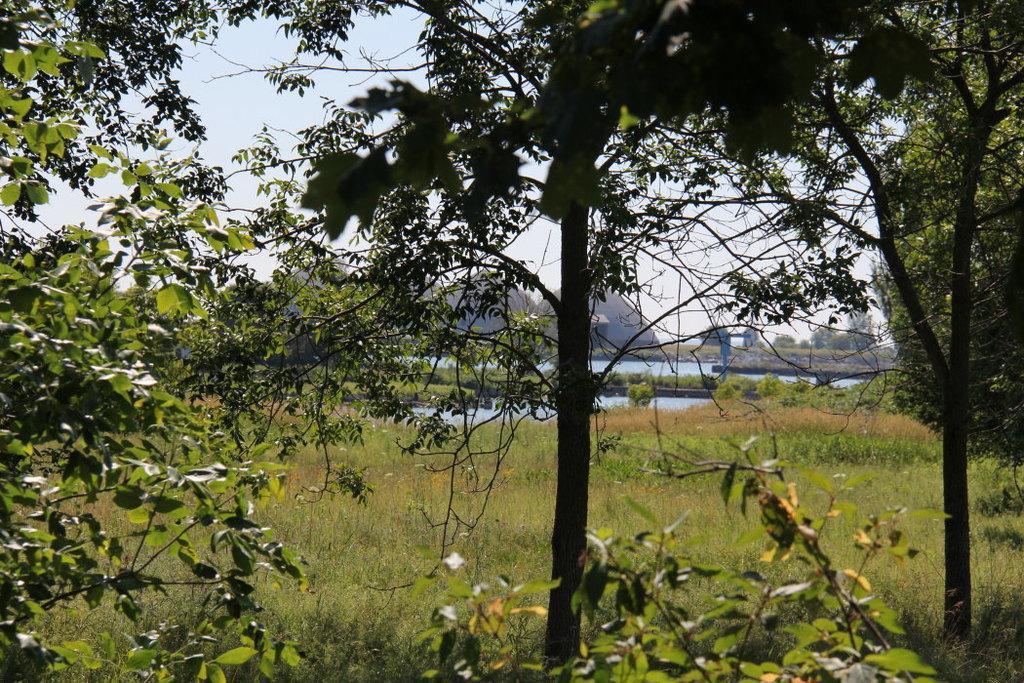Can you describe this image briefly? There are trees. On the ground there are grasses. In the back there is water and sky. 